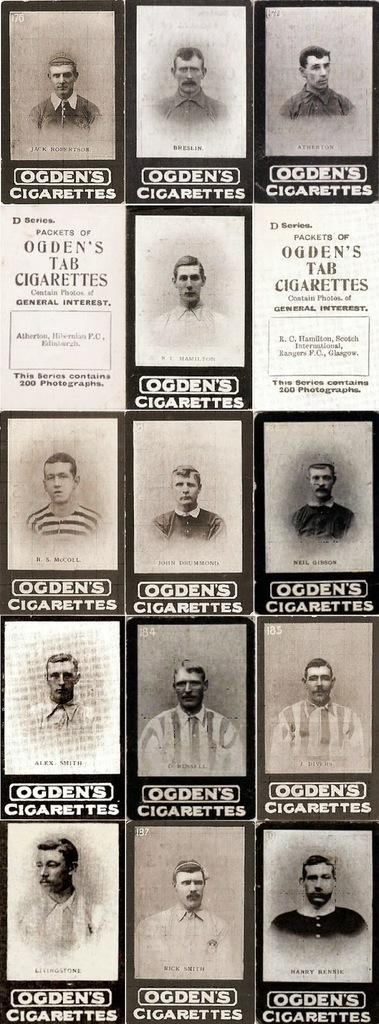What is present in the image? There is a poster in the image. What can be seen on the poster? The poster contains photographs of people. How many cubs are visible in the image? There are no cubs present in the image; it features a poster with photographs of people. What color are the eyes of the person in the image? The image does not provide enough detail to determine the color of the eyes of the person in the photograph. 